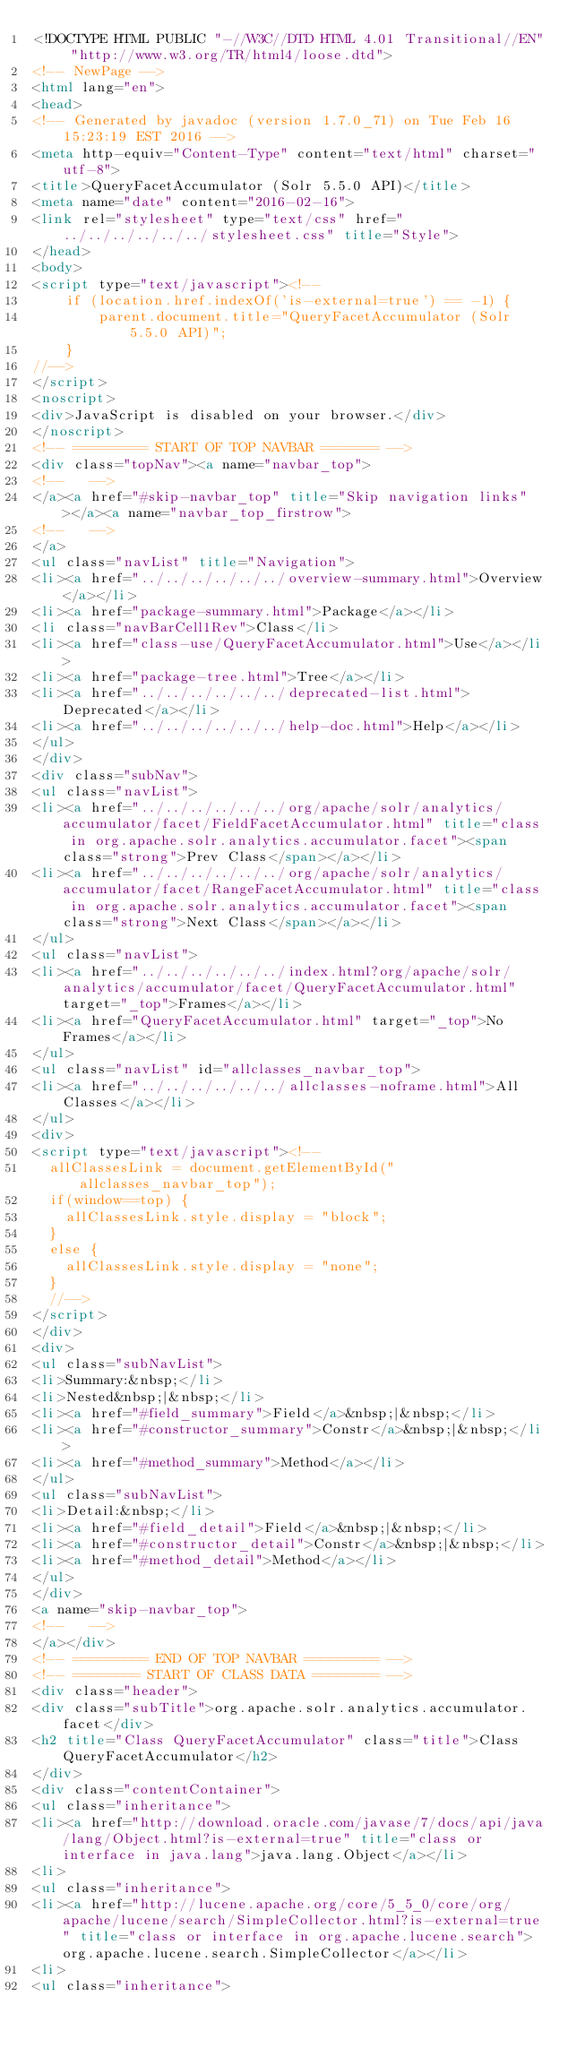<code> <loc_0><loc_0><loc_500><loc_500><_HTML_><!DOCTYPE HTML PUBLIC "-//W3C//DTD HTML 4.01 Transitional//EN" "http://www.w3.org/TR/html4/loose.dtd">
<!-- NewPage -->
<html lang="en">
<head>
<!-- Generated by javadoc (version 1.7.0_71) on Tue Feb 16 15:23:19 EST 2016 -->
<meta http-equiv="Content-Type" content="text/html" charset="utf-8">
<title>QueryFacetAccumulator (Solr 5.5.0 API)</title>
<meta name="date" content="2016-02-16">
<link rel="stylesheet" type="text/css" href="../../../../../../stylesheet.css" title="Style">
</head>
<body>
<script type="text/javascript"><!--
    if (location.href.indexOf('is-external=true') == -1) {
        parent.document.title="QueryFacetAccumulator (Solr 5.5.0 API)";
    }
//-->
</script>
<noscript>
<div>JavaScript is disabled on your browser.</div>
</noscript>
<!-- ========= START OF TOP NAVBAR ======= -->
<div class="topNav"><a name="navbar_top">
<!--   -->
</a><a href="#skip-navbar_top" title="Skip navigation links"></a><a name="navbar_top_firstrow">
<!--   -->
</a>
<ul class="navList" title="Navigation">
<li><a href="../../../../../../overview-summary.html">Overview</a></li>
<li><a href="package-summary.html">Package</a></li>
<li class="navBarCell1Rev">Class</li>
<li><a href="class-use/QueryFacetAccumulator.html">Use</a></li>
<li><a href="package-tree.html">Tree</a></li>
<li><a href="../../../../../../deprecated-list.html">Deprecated</a></li>
<li><a href="../../../../../../help-doc.html">Help</a></li>
</ul>
</div>
<div class="subNav">
<ul class="navList">
<li><a href="../../../../../../org/apache/solr/analytics/accumulator/facet/FieldFacetAccumulator.html" title="class in org.apache.solr.analytics.accumulator.facet"><span class="strong">Prev Class</span></a></li>
<li><a href="../../../../../../org/apache/solr/analytics/accumulator/facet/RangeFacetAccumulator.html" title="class in org.apache.solr.analytics.accumulator.facet"><span class="strong">Next Class</span></a></li>
</ul>
<ul class="navList">
<li><a href="../../../../../../index.html?org/apache/solr/analytics/accumulator/facet/QueryFacetAccumulator.html" target="_top">Frames</a></li>
<li><a href="QueryFacetAccumulator.html" target="_top">No Frames</a></li>
</ul>
<ul class="navList" id="allclasses_navbar_top">
<li><a href="../../../../../../allclasses-noframe.html">All Classes</a></li>
</ul>
<div>
<script type="text/javascript"><!--
  allClassesLink = document.getElementById("allclasses_navbar_top");
  if(window==top) {
    allClassesLink.style.display = "block";
  }
  else {
    allClassesLink.style.display = "none";
  }
  //-->
</script>
</div>
<div>
<ul class="subNavList">
<li>Summary:&nbsp;</li>
<li>Nested&nbsp;|&nbsp;</li>
<li><a href="#field_summary">Field</a>&nbsp;|&nbsp;</li>
<li><a href="#constructor_summary">Constr</a>&nbsp;|&nbsp;</li>
<li><a href="#method_summary">Method</a></li>
</ul>
<ul class="subNavList">
<li>Detail:&nbsp;</li>
<li><a href="#field_detail">Field</a>&nbsp;|&nbsp;</li>
<li><a href="#constructor_detail">Constr</a>&nbsp;|&nbsp;</li>
<li><a href="#method_detail">Method</a></li>
</ul>
</div>
<a name="skip-navbar_top">
<!--   -->
</a></div>
<!-- ========= END OF TOP NAVBAR ========= -->
<!-- ======== START OF CLASS DATA ======== -->
<div class="header">
<div class="subTitle">org.apache.solr.analytics.accumulator.facet</div>
<h2 title="Class QueryFacetAccumulator" class="title">Class QueryFacetAccumulator</h2>
</div>
<div class="contentContainer">
<ul class="inheritance">
<li><a href="http://download.oracle.com/javase/7/docs/api/java/lang/Object.html?is-external=true" title="class or interface in java.lang">java.lang.Object</a></li>
<li>
<ul class="inheritance">
<li><a href="http://lucene.apache.org/core/5_5_0/core/org/apache/lucene/search/SimpleCollector.html?is-external=true" title="class or interface in org.apache.lucene.search">org.apache.lucene.search.SimpleCollector</a></li>
<li>
<ul class="inheritance"></code> 